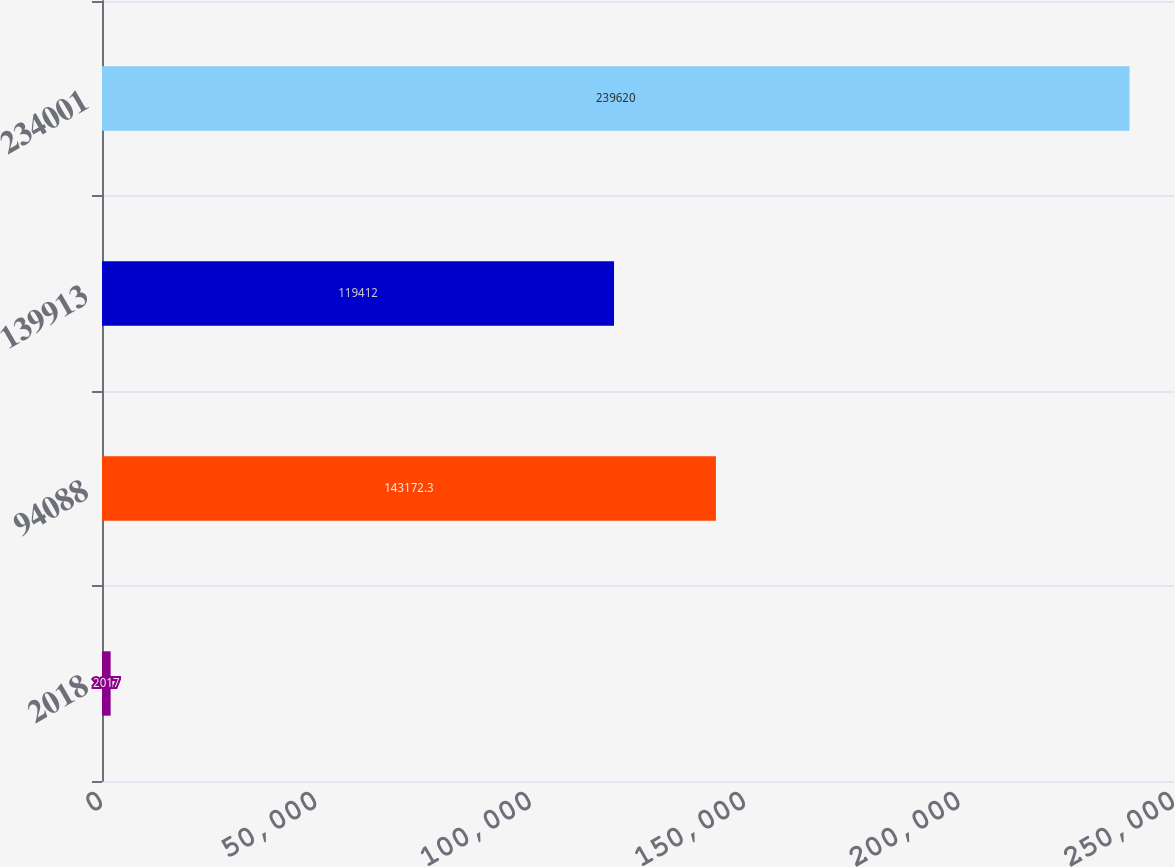Convert chart. <chart><loc_0><loc_0><loc_500><loc_500><bar_chart><fcel>2018<fcel>94088<fcel>139913<fcel>234001<nl><fcel>2017<fcel>143172<fcel>119412<fcel>239620<nl></chart> 